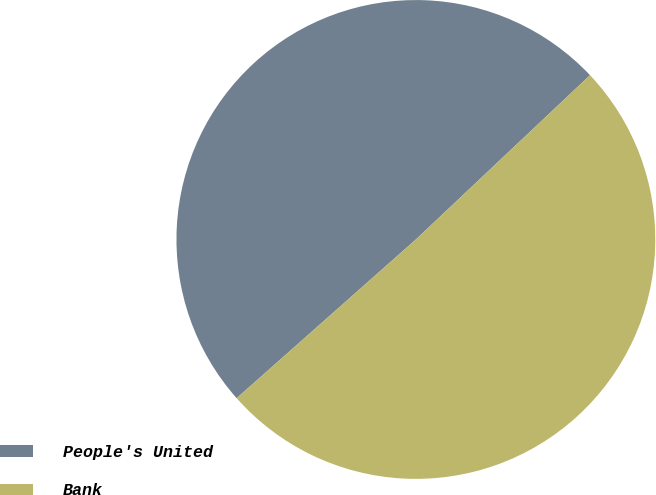<chart> <loc_0><loc_0><loc_500><loc_500><pie_chart><fcel>People's United<fcel>Bank<nl><fcel>49.5%<fcel>50.5%<nl></chart> 